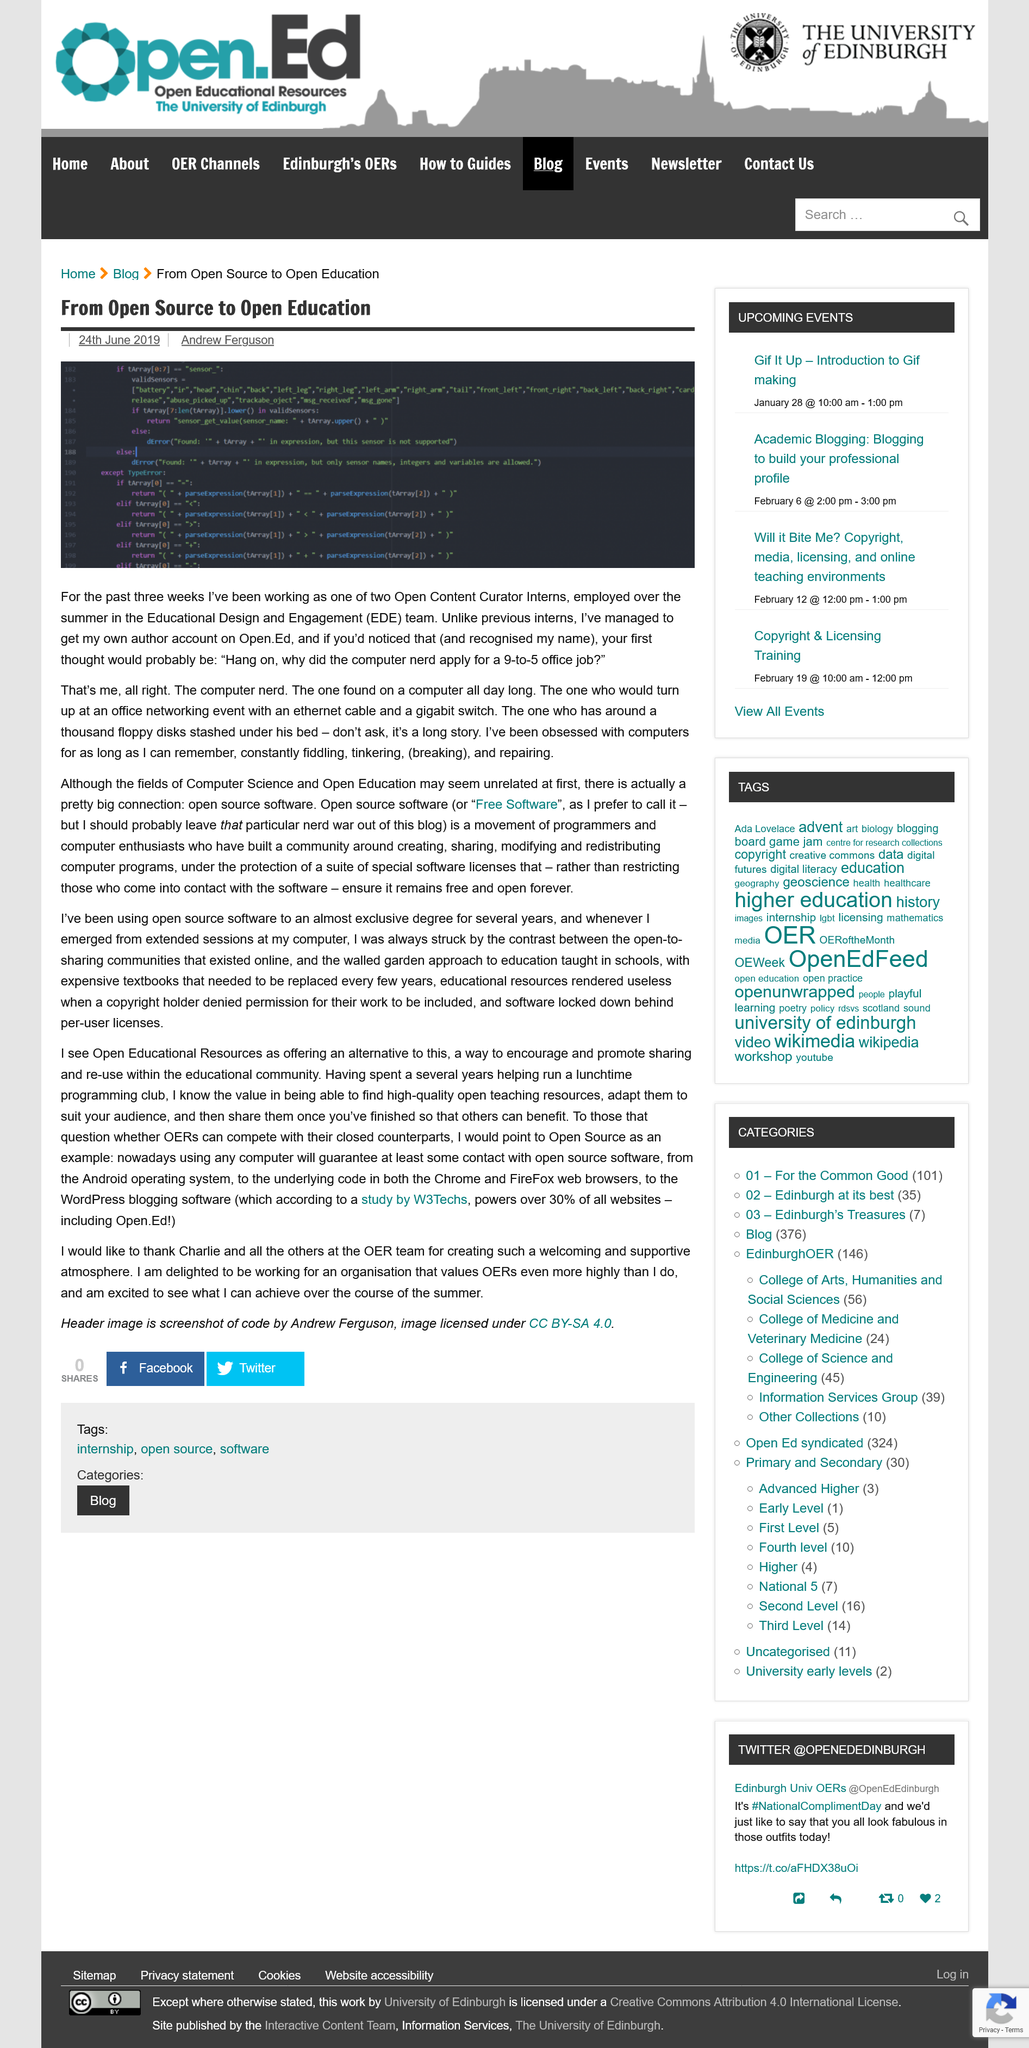List a handful of essential elements in this visual. Yes, the Android operating system is open source software. Today, using a computer inevitably leads to some interaction with open source software. Andrew Ferguson is the author of this piece. The person who wishes to thank Charlie spent several years helping run a lunchtime programming club. Open source software is protected by a set of special software licenses. 